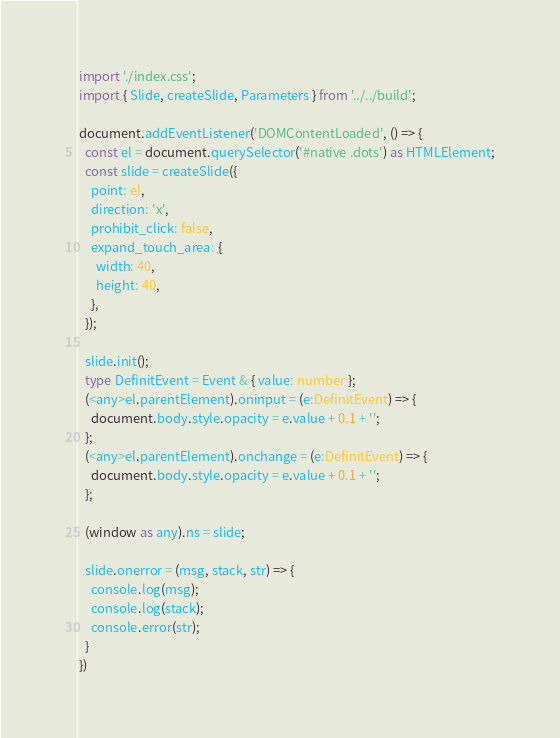Convert code to text. <code><loc_0><loc_0><loc_500><loc_500><_TypeScript_>import './index.css';
import { Slide, createSlide, Parameters } from '../../build';

document.addEventListener('DOMContentLoaded', () => {
  const el = document.querySelector('#native .dots') as HTMLElement;
  const slide = createSlide({
    point: el,
    direction: 'x',
    prohibit_click: false,
    expand_touch_area: {
      width: 40,
      height: 40,
    },
  });

  slide.init();
  type DefinitEvent = Event & { value: number };
  (<any>el.parentElement).oninput = (e:DefinitEvent) => {
    document.body.style.opacity = e.value + 0.1 + '';
  };
  (<any>el.parentElement).onchange = (e:DefinitEvent) => {
    document.body.style.opacity = e.value + 0.1 + '';
  };

  (window as any).ns = slide;

  slide.onerror = (msg, stack, str) => {
    console.log(msg);
    console.log(stack);
    console.error(str);
  }
})
</code> 